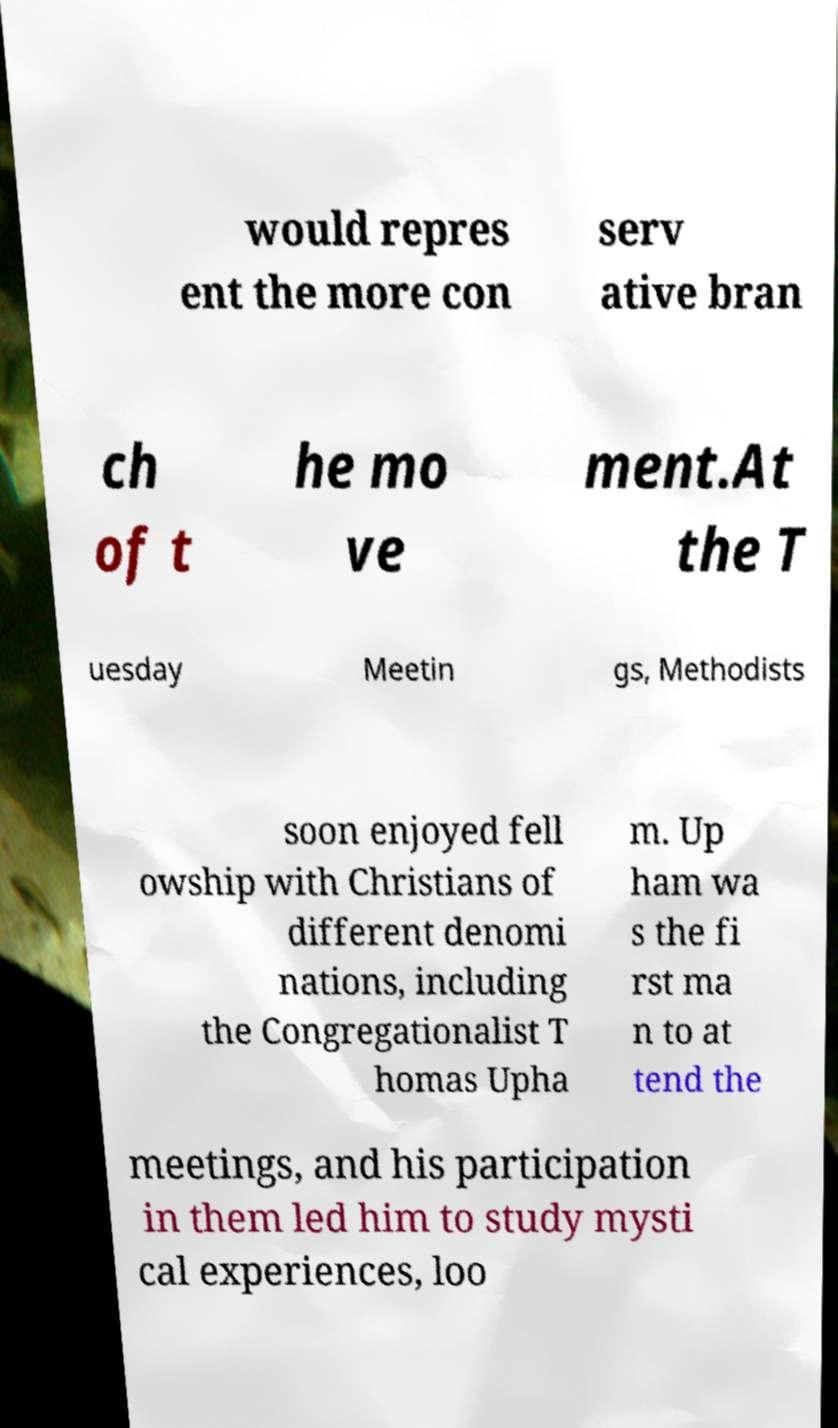Can you accurately transcribe the text from the provided image for me? would repres ent the more con serv ative bran ch of t he mo ve ment.At the T uesday Meetin gs, Methodists soon enjoyed fell owship with Christians of different denomi nations, including the Congregationalist T homas Upha m. Up ham wa s the fi rst ma n to at tend the meetings, and his participation in them led him to study mysti cal experiences, loo 